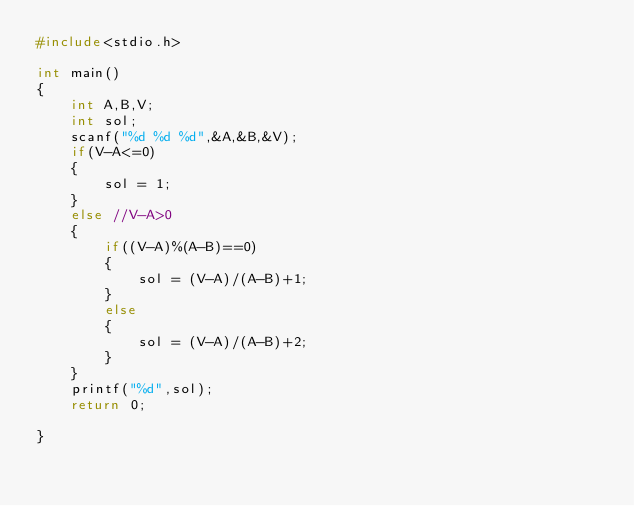<code> <loc_0><loc_0><loc_500><loc_500><_C_>#include<stdio.h>

int main()
{
    int A,B,V;
    int sol;
    scanf("%d %d %d",&A,&B,&V);
    if(V-A<=0) 
    {
        sol = 1;
    }
    else //V-A>0
    {
        if((V-A)%(A-B)==0)
        {
            sol = (V-A)/(A-B)+1;
        }
        else
        {
            sol = (V-A)/(A-B)+2;
        }
    }
    printf("%d",sol);
    return 0;
    
}</code> 